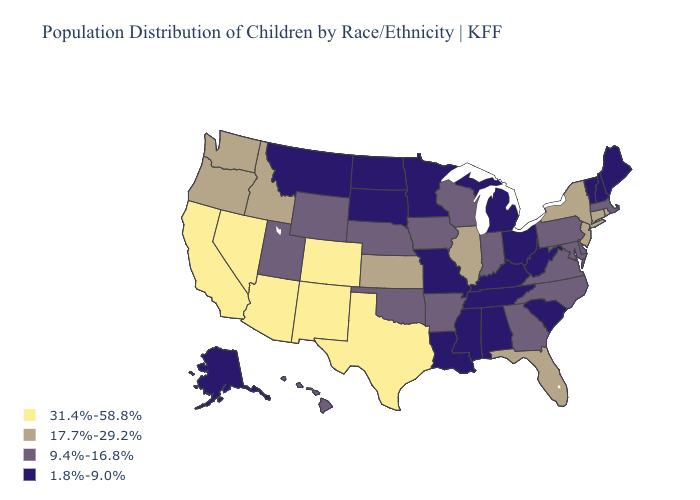Name the states that have a value in the range 17.7%-29.2%?
Short answer required. Connecticut, Florida, Idaho, Illinois, Kansas, New Jersey, New York, Oregon, Rhode Island, Washington. Name the states that have a value in the range 17.7%-29.2%?
Quick response, please. Connecticut, Florida, Idaho, Illinois, Kansas, New Jersey, New York, Oregon, Rhode Island, Washington. Does Michigan have the highest value in the USA?
Keep it brief. No. Among the states that border Alabama , which have the highest value?
Write a very short answer. Florida. What is the highest value in the USA?
Quick response, please. 31.4%-58.8%. Which states hav the highest value in the South?
Give a very brief answer. Texas. Is the legend a continuous bar?
Write a very short answer. No. What is the highest value in states that border Nevada?
Short answer required. 31.4%-58.8%. What is the value of Texas?
Write a very short answer. 31.4%-58.8%. What is the value of New Hampshire?
Be succinct. 1.8%-9.0%. Does Alaska have the lowest value in the USA?
Keep it brief. Yes. What is the lowest value in the West?
Give a very brief answer. 1.8%-9.0%. What is the lowest value in the MidWest?
Keep it brief. 1.8%-9.0%. Which states have the highest value in the USA?
Quick response, please. Arizona, California, Colorado, Nevada, New Mexico, Texas. How many symbols are there in the legend?
Concise answer only. 4. 